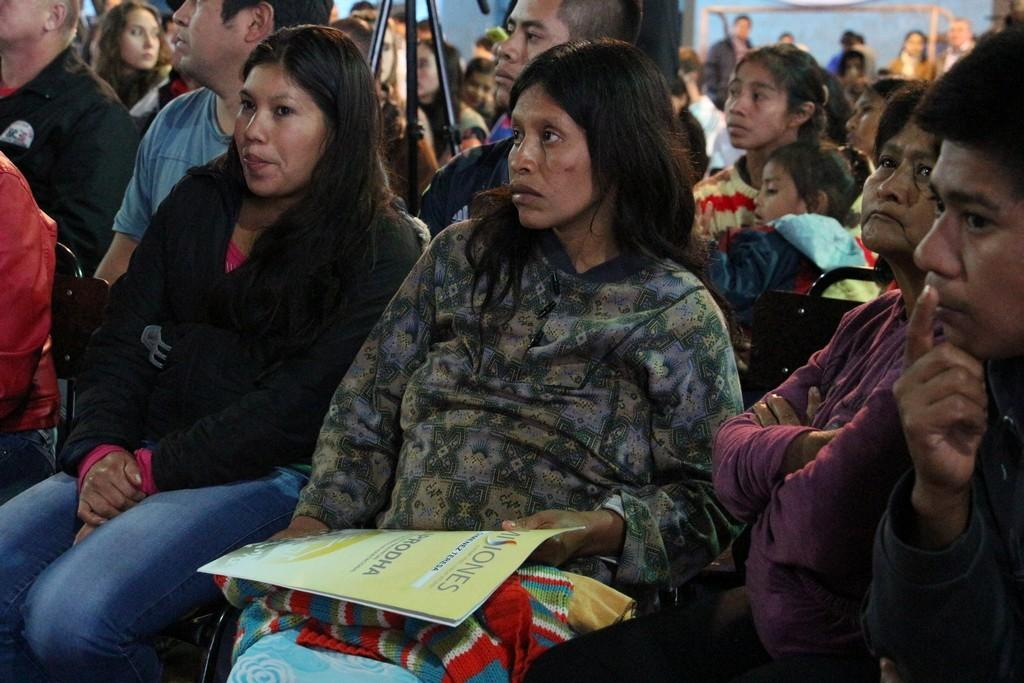What are the people in the image doing? There is a group of people sitting on chairs in the image. What object can be seen in the image that is typically used for photography or videography? There is a tripod stand in the image. What is the woman holding in the image? The woman is holding a file and a sweater. Can you describe the people in the background of the image? There are people standing in the background of the image. What news is being reported by the team in the image? There is no team or news reporting present in the image. What level of difficulty is the challenge being faced by the team in the image? There is no challenge or team present in the image. 